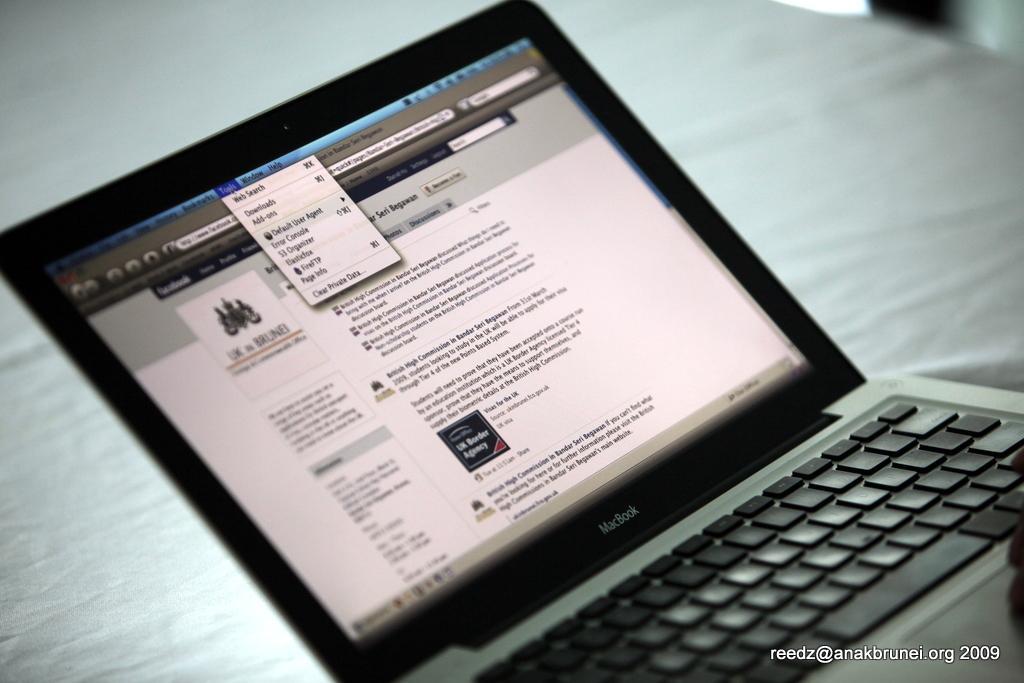Describe this image in one or two sentences. In this image we can see a laptop with screen and keyboard. At the bottom we can see the text. 